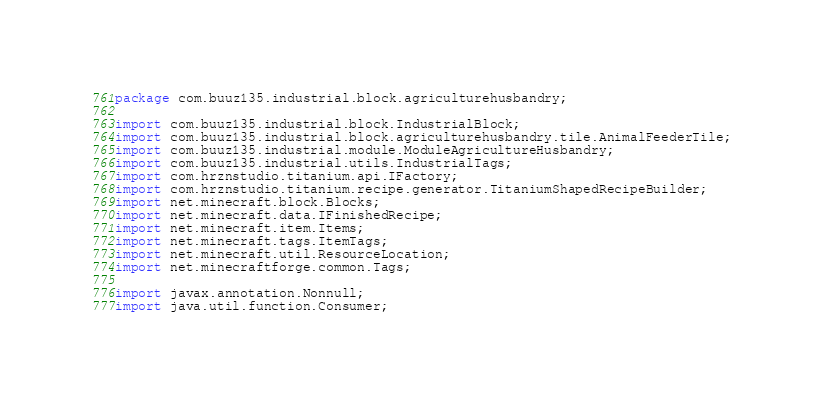<code> <loc_0><loc_0><loc_500><loc_500><_Java_>package com.buuz135.industrial.block.agriculturehusbandry;

import com.buuz135.industrial.block.IndustrialBlock;
import com.buuz135.industrial.block.agriculturehusbandry.tile.AnimalFeederTile;
import com.buuz135.industrial.module.ModuleAgricultureHusbandry;
import com.buuz135.industrial.utils.IndustrialTags;
import com.hrznstudio.titanium.api.IFactory;
import com.hrznstudio.titanium.recipe.generator.TitaniumShapedRecipeBuilder;
import net.minecraft.block.Blocks;
import net.minecraft.data.IFinishedRecipe;
import net.minecraft.item.Items;
import net.minecraft.tags.ItemTags;
import net.minecraft.util.ResourceLocation;
import net.minecraftforge.common.Tags;

import javax.annotation.Nonnull;
import java.util.function.Consumer;
</code> 